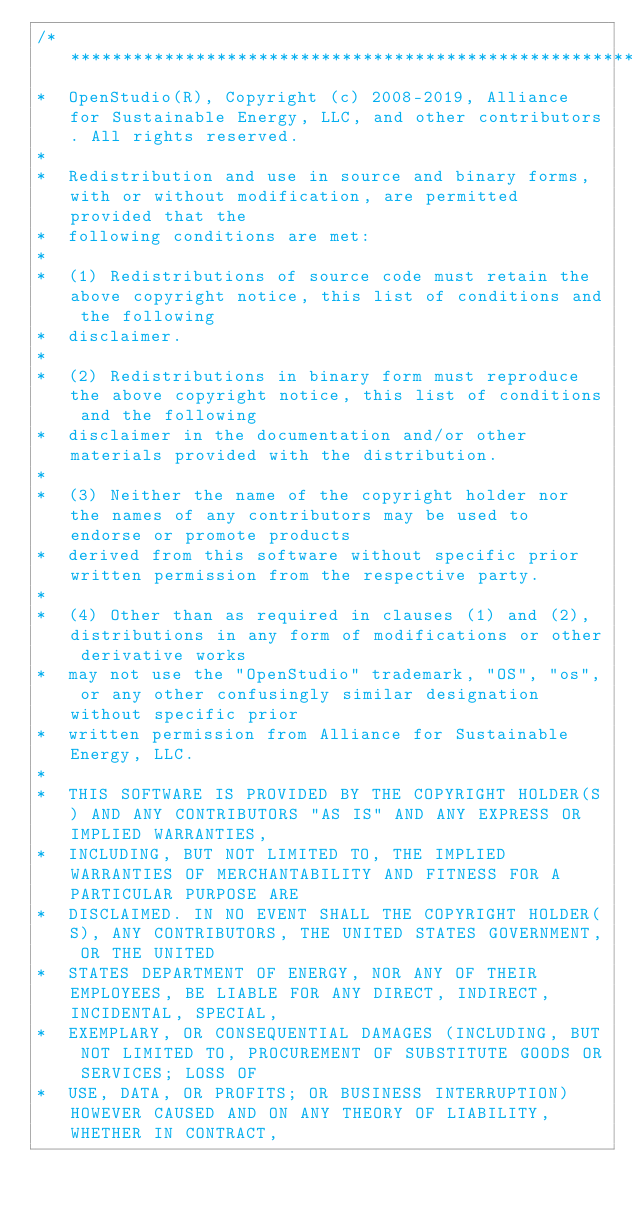Convert code to text. <code><loc_0><loc_0><loc_500><loc_500><_C++_>/***********************************************************************************************************************
*  OpenStudio(R), Copyright (c) 2008-2019, Alliance for Sustainable Energy, LLC, and other contributors. All rights reserved.
*
*  Redistribution and use in source and binary forms, with or without modification, are permitted provided that the
*  following conditions are met:
*
*  (1) Redistributions of source code must retain the above copyright notice, this list of conditions and the following
*  disclaimer.
*
*  (2) Redistributions in binary form must reproduce the above copyright notice, this list of conditions and the following
*  disclaimer in the documentation and/or other materials provided with the distribution.
*
*  (3) Neither the name of the copyright holder nor the names of any contributors may be used to endorse or promote products
*  derived from this software without specific prior written permission from the respective party.
*
*  (4) Other than as required in clauses (1) and (2), distributions in any form of modifications or other derivative works
*  may not use the "OpenStudio" trademark, "OS", "os", or any other confusingly similar designation without specific prior
*  written permission from Alliance for Sustainable Energy, LLC.
*
*  THIS SOFTWARE IS PROVIDED BY THE COPYRIGHT HOLDER(S) AND ANY CONTRIBUTORS "AS IS" AND ANY EXPRESS OR IMPLIED WARRANTIES,
*  INCLUDING, BUT NOT LIMITED TO, THE IMPLIED WARRANTIES OF MERCHANTABILITY AND FITNESS FOR A PARTICULAR PURPOSE ARE
*  DISCLAIMED. IN NO EVENT SHALL THE COPYRIGHT HOLDER(S), ANY CONTRIBUTORS, THE UNITED STATES GOVERNMENT, OR THE UNITED
*  STATES DEPARTMENT OF ENERGY, NOR ANY OF THEIR EMPLOYEES, BE LIABLE FOR ANY DIRECT, INDIRECT, INCIDENTAL, SPECIAL,
*  EXEMPLARY, OR CONSEQUENTIAL DAMAGES (INCLUDING, BUT NOT LIMITED TO, PROCUREMENT OF SUBSTITUTE GOODS OR SERVICES; LOSS OF
*  USE, DATA, OR PROFITS; OR BUSINESS INTERRUPTION) HOWEVER CAUSED AND ON ANY THEORY OF LIABILITY, WHETHER IN CONTRACT,</code> 